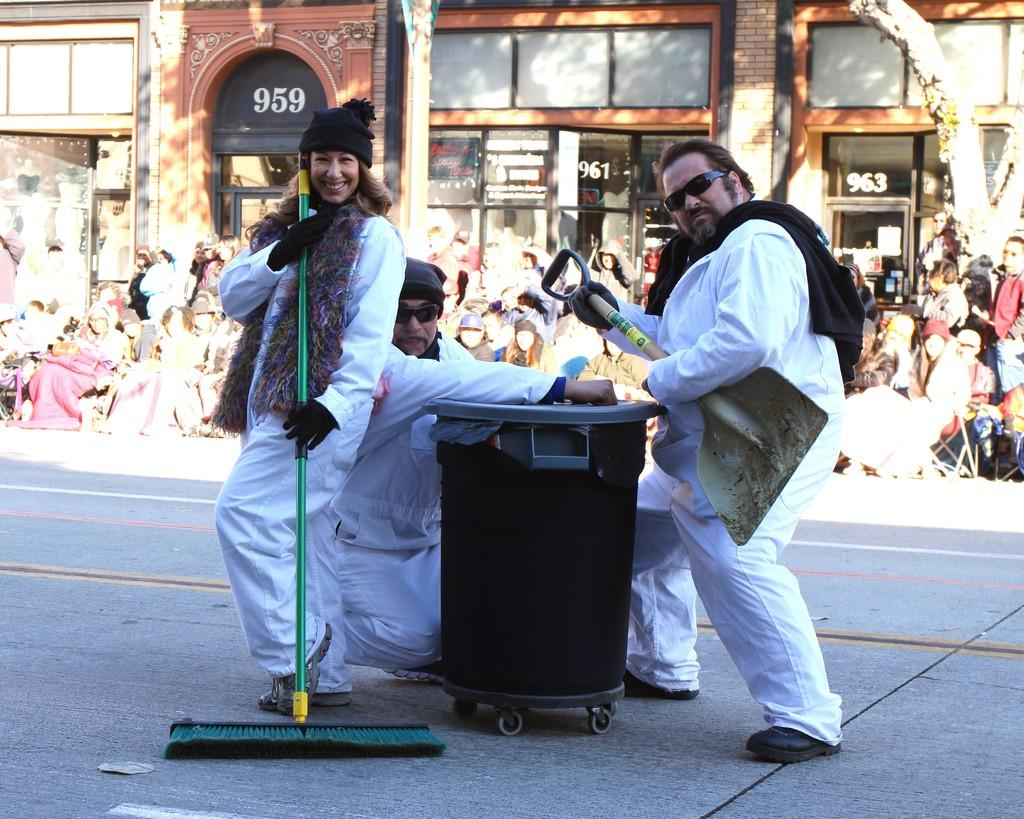Provide a one-sentence caption for the provided image. garbage cleaning people standing in the street in front of building 963. 